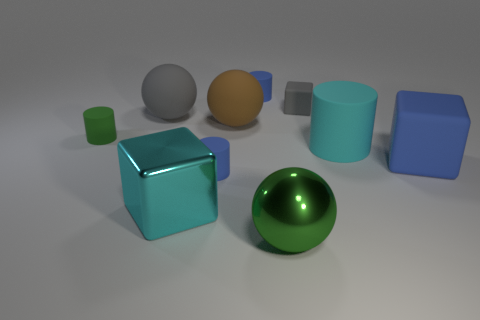Subtract all cylinders. How many objects are left? 6 Subtract all large shiny cubes. Subtract all blue things. How many objects are left? 6 Add 6 small blue rubber objects. How many small blue rubber objects are left? 8 Add 3 gray spheres. How many gray spheres exist? 4 Subtract 0 red spheres. How many objects are left? 10 